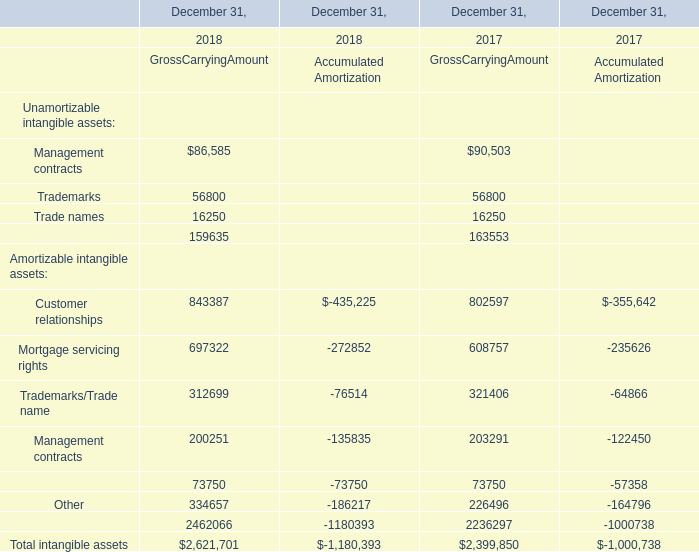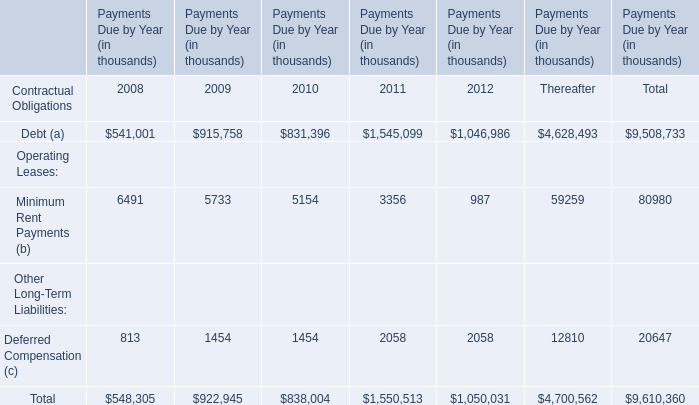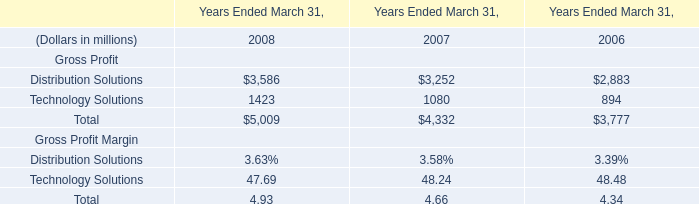What will mortgage servicing rights of Gross carrying amount reach in 2019 if it continues to grow at its current rate? 
Computations: ((((697322 - 608757) / 608757) + 1) * 697322)
Answer: 798771.87726. 